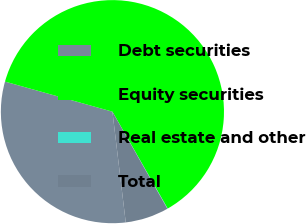Convert chart. <chart><loc_0><loc_0><loc_500><loc_500><pie_chart><fcel>Debt securities<fcel>Equity securities<fcel>Real estate and other<fcel>Total<nl><fcel>31.25%<fcel>62.41%<fcel>0.05%<fcel>6.29%<nl></chart> 